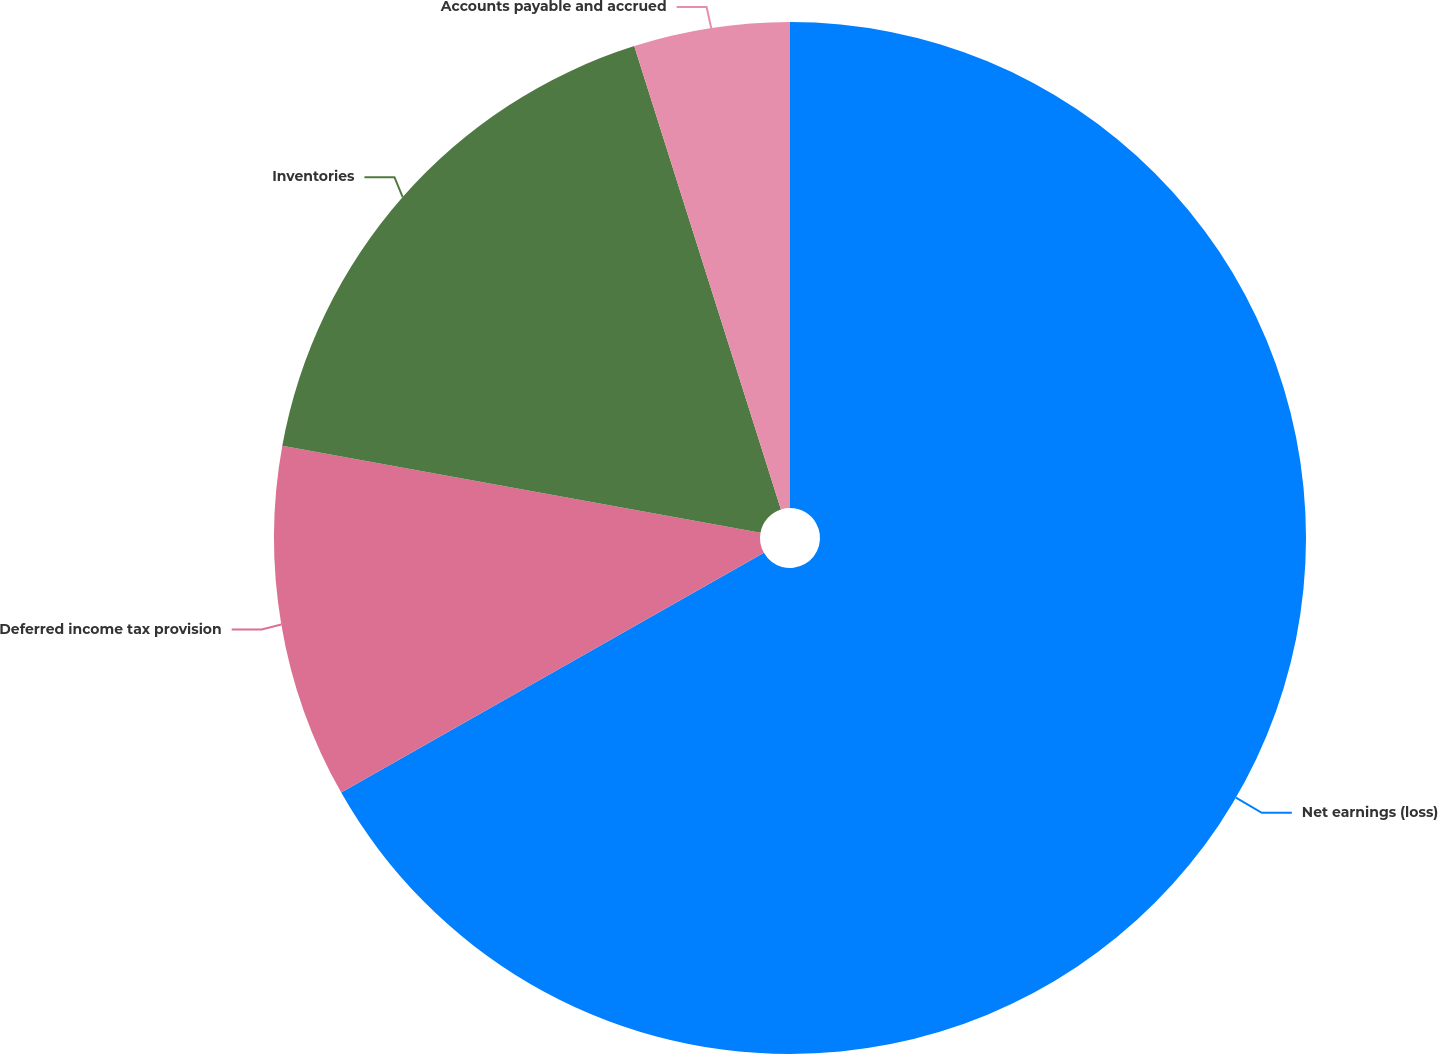<chart> <loc_0><loc_0><loc_500><loc_500><pie_chart><fcel>Net earnings (loss)<fcel>Deferred income tax provision<fcel>Inventories<fcel>Accounts payable and accrued<nl><fcel>66.78%<fcel>11.07%<fcel>17.26%<fcel>4.88%<nl></chart> 